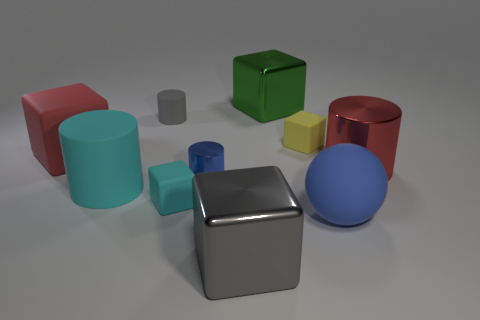There is a big gray shiny thing; what shape is it?
Offer a terse response. Cube. There is a rubber cube that is behind the red matte cube; what is its size?
Your response must be concise. Small. The other cylinder that is the same size as the gray rubber cylinder is what color?
Give a very brief answer. Blue. Are there any small matte blocks of the same color as the small rubber cylinder?
Your answer should be compact. No. Are there fewer gray shiny blocks that are behind the large red block than big cyan matte cylinders that are behind the tiny gray matte cylinder?
Give a very brief answer. No. What material is the large block that is in front of the big green block and right of the tiny gray rubber thing?
Offer a terse response. Metal. Do the small cyan rubber object and the red thing that is right of the big rubber block have the same shape?
Keep it short and to the point. No. What number of other objects are the same size as the red cylinder?
Keep it short and to the point. 5. Is the number of small blue balls greater than the number of yellow matte objects?
Provide a short and direct response. No. How many large blocks are behind the big shiny cylinder and in front of the tiny blue thing?
Offer a terse response. 0. 